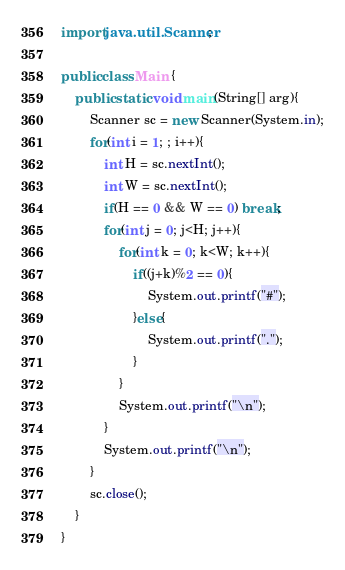Convert code to text. <code><loc_0><loc_0><loc_500><loc_500><_Java_>import java.util.Scanner;

public class Main {
    public static void main(String[] arg){
        Scanner sc = new Scanner(System.in);
        for(int i = 1; ; i++){
            int H = sc.nextInt();
            int W = sc.nextInt();
            if(H == 0 && W == 0) break;
            for(int j = 0; j<H; j++){
                for(int k = 0; k<W; k++){
                    if((j+k)%2 == 0){
                        System.out.printf("#");
                    }else{
                        System.out.printf(".");
                    }
                }
                System.out.printf("\n");
            }
            System.out.printf("\n");
        }
        sc.close();
    }
}
</code> 